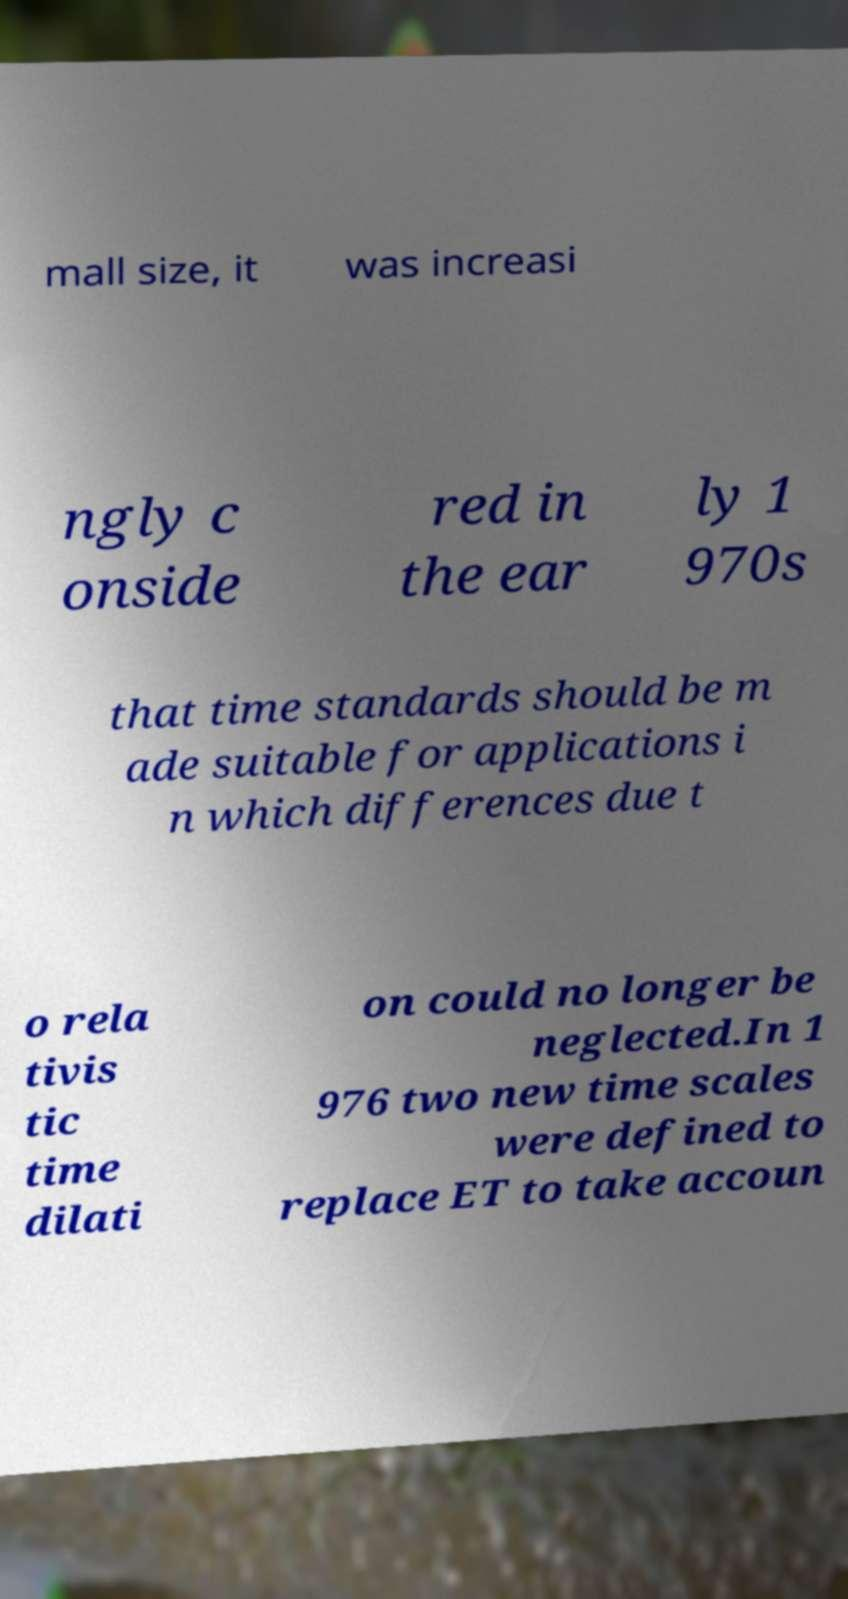Please identify and transcribe the text found in this image. mall size, it was increasi ngly c onside red in the ear ly 1 970s that time standards should be m ade suitable for applications i n which differences due t o rela tivis tic time dilati on could no longer be neglected.In 1 976 two new time scales were defined to replace ET to take accoun 